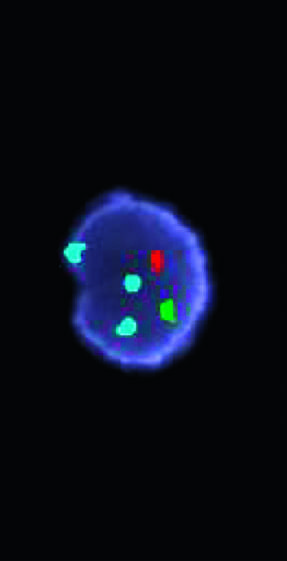does the green probe hybridize to the x chromosome centromere (one copy), the red probe to the y chromosome centromere (one copy), and the aqua probe to the chromosome 18 centromere (three copies)?
Answer the question using a single word or phrase. Yes 